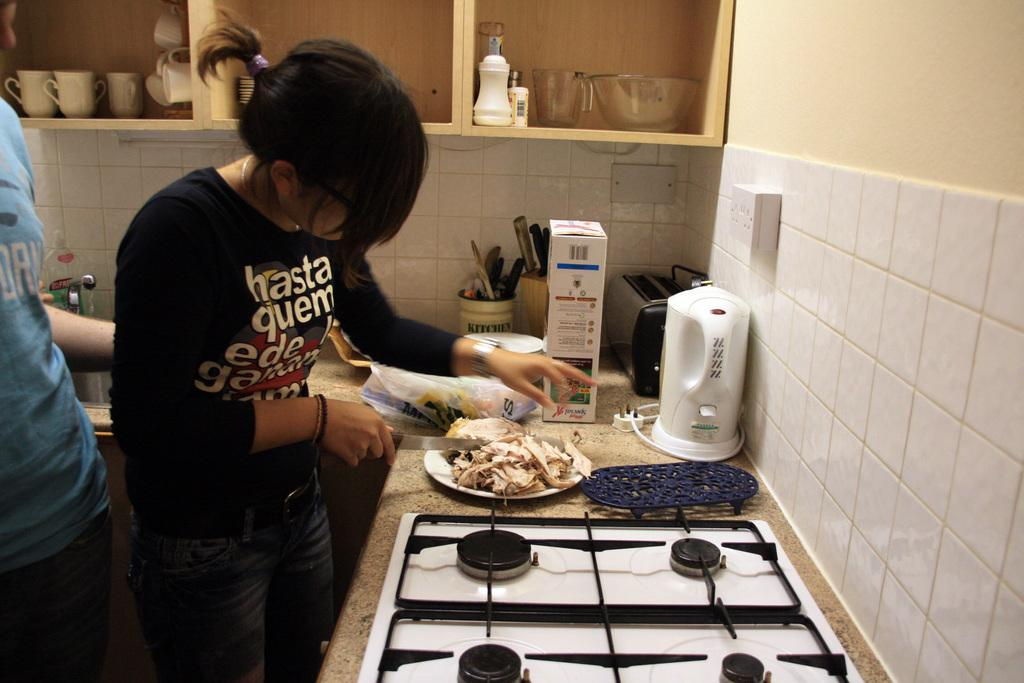<image>
Offer a succinct explanation of the picture presented. A women wearing a tee shirt that starts hasta quem is cutting chicken into strips onto a plate. 